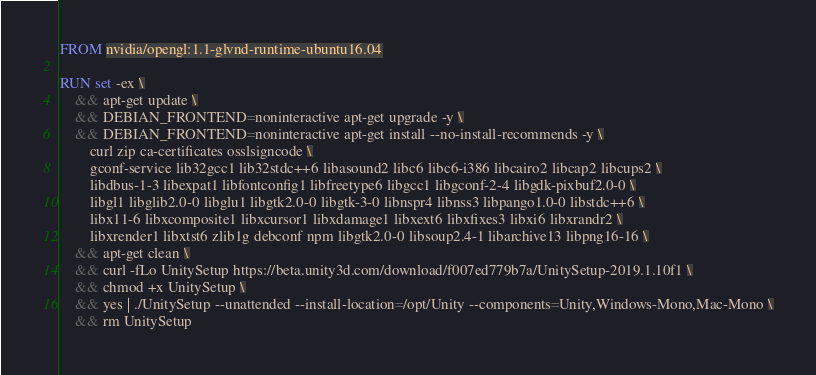<code> <loc_0><loc_0><loc_500><loc_500><_Dockerfile_>FROM nvidia/opengl:1.1-glvnd-runtime-ubuntu16.04

RUN set -ex \
    && apt-get update \
    && DEBIAN_FRONTEND=noninteractive apt-get upgrade -y \
    && DEBIAN_FRONTEND=noninteractive apt-get install --no-install-recommends -y \
        curl zip ca-certificates osslsigncode \
        gconf-service lib32gcc1 lib32stdc++6 libasound2 libc6 libc6-i386 libcairo2 libcap2 libcups2 \
        libdbus-1-3 libexpat1 libfontconfig1 libfreetype6 libgcc1 libgconf-2-4 libgdk-pixbuf2.0-0 \
        libgl1 libglib2.0-0 libglu1 libgtk2.0-0 libgtk-3-0 libnspr4 libnss3 libpango1.0-0 libstdc++6 \
        libx11-6 libxcomposite1 libxcursor1 libxdamage1 libxext6 libxfixes3 libxi6 libxrandr2 \
        libxrender1 libxtst6 zlib1g debconf npm libgtk2.0-0 libsoup2.4-1 libarchive13 libpng16-16 \
    && apt-get clean \
    && curl -fLo UnitySetup https://beta.unity3d.com/download/f007ed779b7a/UnitySetup-2019.1.10f1 \
    && chmod +x UnitySetup \
    && yes | ./UnitySetup --unattended --install-location=/opt/Unity --components=Unity,Windows-Mono,Mac-Mono \
    && rm UnitySetup
</code> 